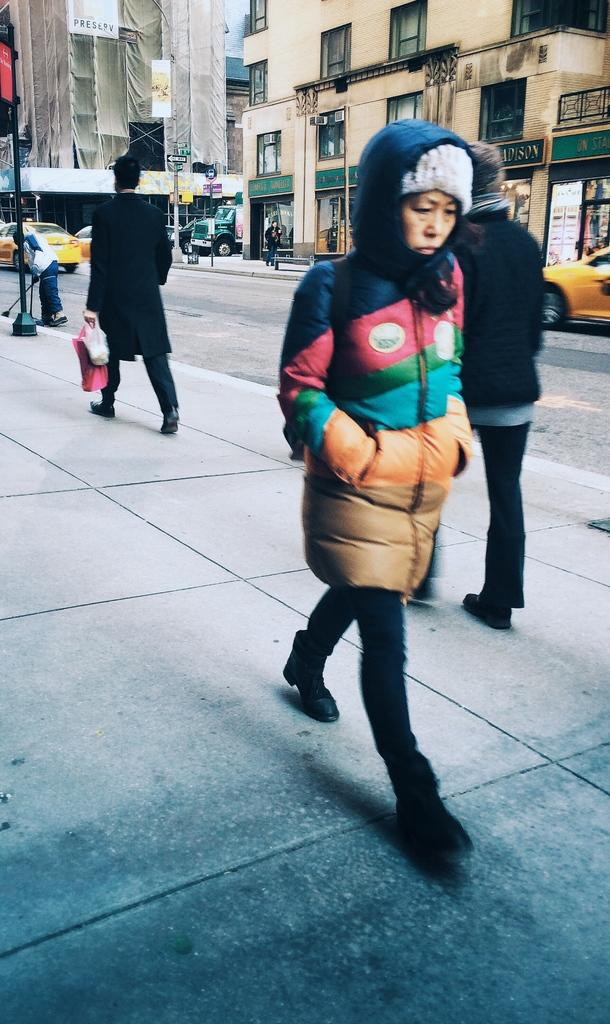What are the people in the image doing? The people in the image are walking on a path. What else can be seen on the ground in the image? There are vehicles on the road in the image. What is visible in the distance in the image? There are buildings in the background of the image. What objects are standing upright in the image? Poles are visible in the image. What type of rhythm can be heard from the people walking in the image? There is no sound or rhythm associated with the people walking in the image; it is a still image. 